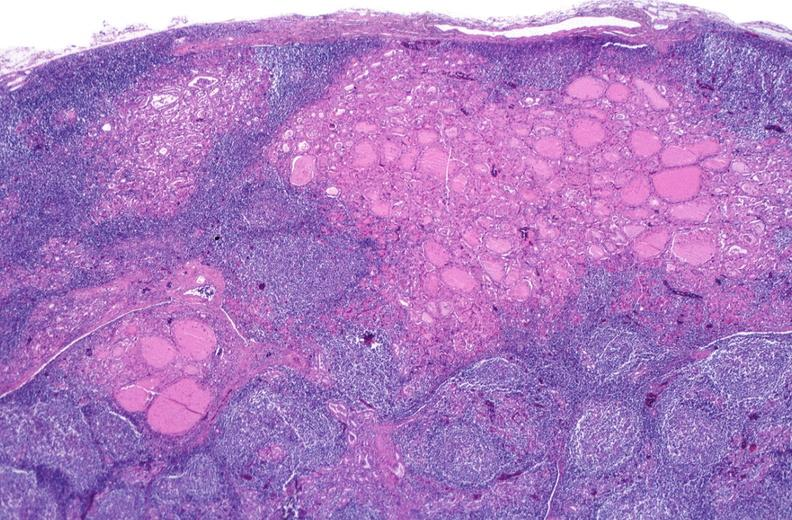s atrophy present?
Answer the question using a single word or phrase. No 